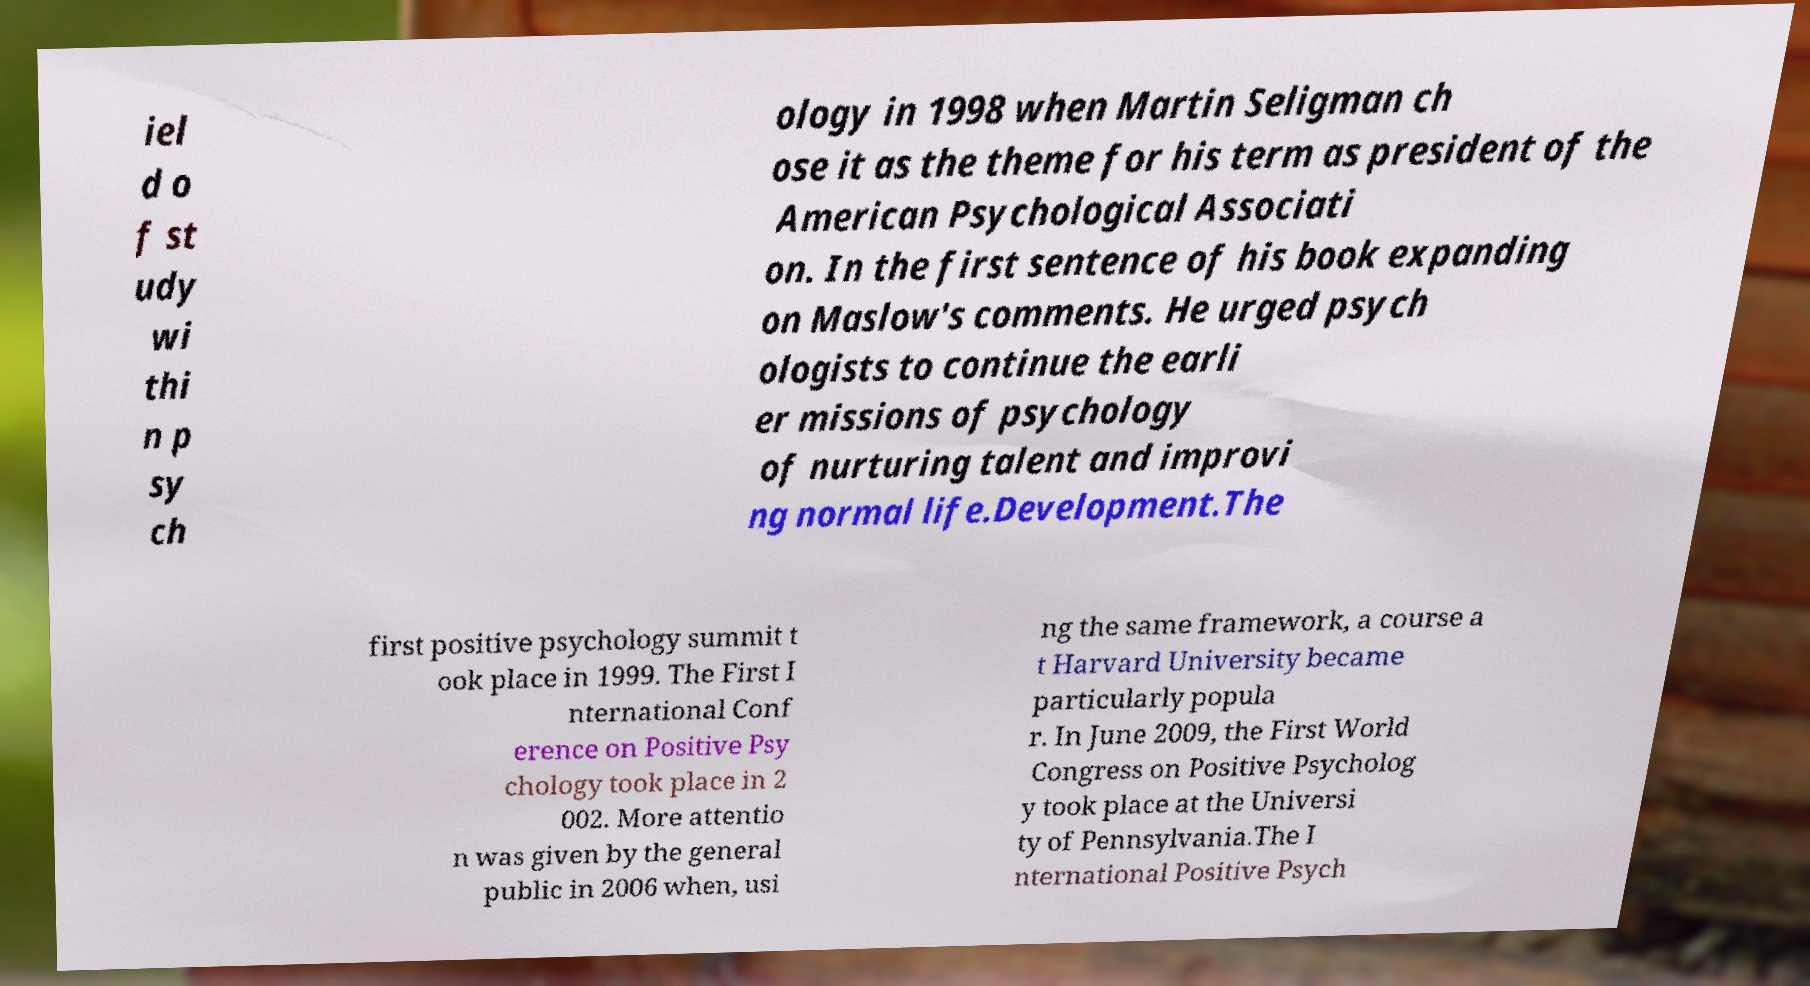Please read and relay the text visible in this image. What does it say? iel d o f st udy wi thi n p sy ch ology in 1998 when Martin Seligman ch ose it as the theme for his term as president of the American Psychological Associati on. In the first sentence of his book expanding on Maslow's comments. He urged psych ologists to continue the earli er missions of psychology of nurturing talent and improvi ng normal life.Development.The first positive psychology summit t ook place in 1999. The First I nternational Conf erence on Positive Psy chology took place in 2 002. More attentio n was given by the general public in 2006 when, usi ng the same framework, a course a t Harvard University became particularly popula r. In June 2009, the First World Congress on Positive Psycholog y took place at the Universi ty of Pennsylvania.The I nternational Positive Psych 